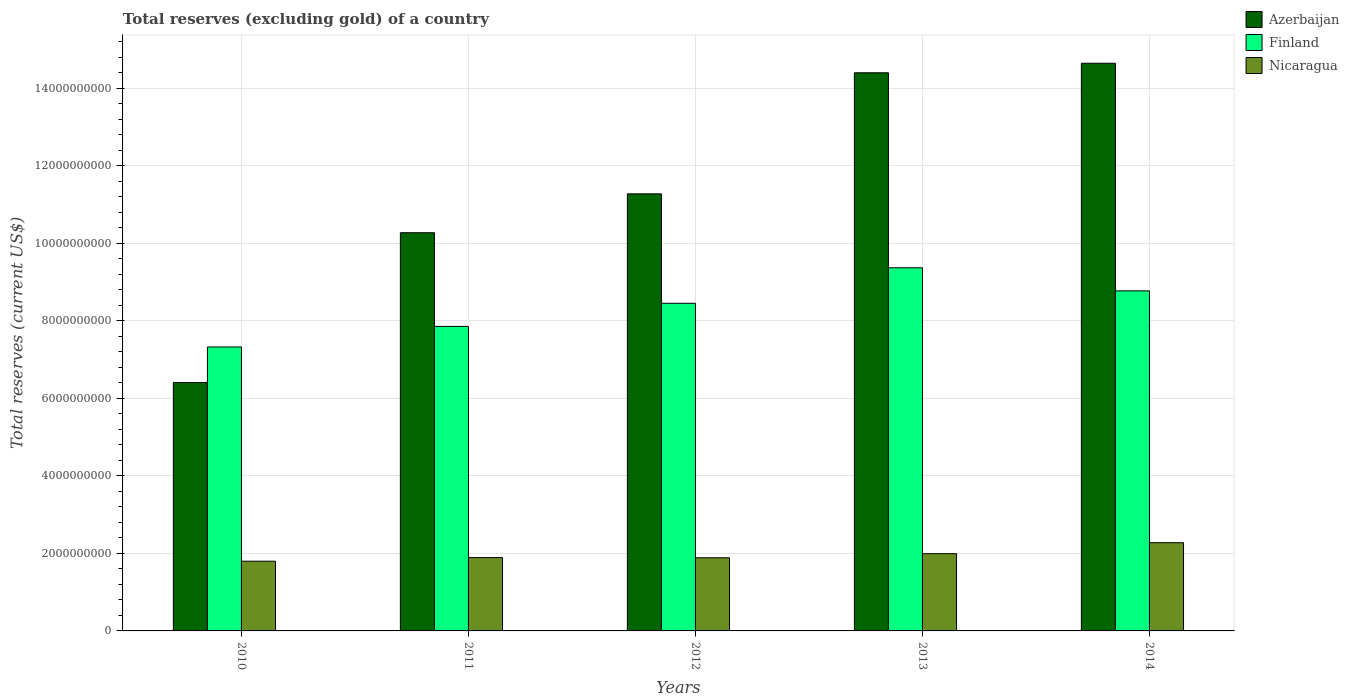Are the number of bars per tick equal to the number of legend labels?
Offer a terse response. Yes. Are the number of bars on each tick of the X-axis equal?
Your response must be concise. Yes. How many bars are there on the 1st tick from the left?
Make the answer very short. 3. How many bars are there on the 3rd tick from the right?
Your answer should be very brief. 3. What is the label of the 4th group of bars from the left?
Provide a succinct answer. 2013. In how many cases, is the number of bars for a given year not equal to the number of legend labels?
Offer a very short reply. 0. What is the total reserves (excluding gold) in Finland in 2010?
Your response must be concise. 7.33e+09. Across all years, what is the maximum total reserves (excluding gold) in Nicaragua?
Make the answer very short. 2.28e+09. Across all years, what is the minimum total reserves (excluding gold) in Nicaragua?
Ensure brevity in your answer.  1.80e+09. What is the total total reserves (excluding gold) in Nicaragua in the graph?
Keep it short and to the point. 9.85e+09. What is the difference between the total reserves (excluding gold) in Azerbaijan in 2011 and that in 2013?
Give a very brief answer. -4.13e+09. What is the difference between the total reserves (excluding gold) in Finland in 2014 and the total reserves (excluding gold) in Azerbaijan in 2012?
Your answer should be very brief. -2.50e+09. What is the average total reserves (excluding gold) in Finland per year?
Your response must be concise. 8.36e+09. In the year 2012, what is the difference between the total reserves (excluding gold) in Azerbaijan and total reserves (excluding gold) in Finland?
Give a very brief answer. 2.82e+09. What is the ratio of the total reserves (excluding gold) in Azerbaijan in 2011 to that in 2013?
Provide a short and direct response. 0.71. Is the total reserves (excluding gold) in Finland in 2011 less than that in 2013?
Your answer should be compact. Yes. What is the difference between the highest and the second highest total reserves (excluding gold) in Azerbaijan?
Provide a succinct answer. 2.46e+08. What is the difference between the highest and the lowest total reserves (excluding gold) in Azerbaijan?
Keep it short and to the point. 8.24e+09. In how many years, is the total reserves (excluding gold) in Finland greater than the average total reserves (excluding gold) in Finland taken over all years?
Provide a succinct answer. 3. Is the sum of the total reserves (excluding gold) in Nicaragua in 2012 and 2013 greater than the maximum total reserves (excluding gold) in Finland across all years?
Provide a short and direct response. No. What does the 1st bar from the left in 2013 represents?
Keep it short and to the point. Azerbaijan. What does the 1st bar from the right in 2013 represents?
Make the answer very short. Nicaragua. Is it the case that in every year, the sum of the total reserves (excluding gold) in Finland and total reserves (excluding gold) in Azerbaijan is greater than the total reserves (excluding gold) in Nicaragua?
Keep it short and to the point. Yes. How many years are there in the graph?
Provide a short and direct response. 5. What is the difference between two consecutive major ticks on the Y-axis?
Your answer should be very brief. 2.00e+09. Are the values on the major ticks of Y-axis written in scientific E-notation?
Provide a short and direct response. No. Does the graph contain any zero values?
Offer a terse response. No. Does the graph contain grids?
Make the answer very short. Yes. What is the title of the graph?
Offer a very short reply. Total reserves (excluding gold) of a country. Does "Zambia" appear as one of the legend labels in the graph?
Offer a terse response. No. What is the label or title of the X-axis?
Your answer should be very brief. Years. What is the label or title of the Y-axis?
Make the answer very short. Total reserves (current US$). What is the Total reserves (current US$) of Azerbaijan in 2010?
Offer a very short reply. 6.41e+09. What is the Total reserves (current US$) in Finland in 2010?
Make the answer very short. 7.33e+09. What is the Total reserves (current US$) in Nicaragua in 2010?
Provide a short and direct response. 1.80e+09. What is the Total reserves (current US$) of Azerbaijan in 2011?
Give a very brief answer. 1.03e+1. What is the Total reserves (current US$) of Finland in 2011?
Your response must be concise. 7.86e+09. What is the Total reserves (current US$) in Nicaragua in 2011?
Your answer should be compact. 1.89e+09. What is the Total reserves (current US$) in Azerbaijan in 2012?
Ensure brevity in your answer.  1.13e+1. What is the Total reserves (current US$) in Finland in 2012?
Ensure brevity in your answer.  8.45e+09. What is the Total reserves (current US$) in Nicaragua in 2012?
Your answer should be very brief. 1.89e+09. What is the Total reserves (current US$) of Azerbaijan in 2013?
Keep it short and to the point. 1.44e+1. What is the Total reserves (current US$) of Finland in 2013?
Ensure brevity in your answer.  9.37e+09. What is the Total reserves (current US$) of Nicaragua in 2013?
Make the answer very short. 1.99e+09. What is the Total reserves (current US$) of Azerbaijan in 2014?
Your answer should be very brief. 1.46e+1. What is the Total reserves (current US$) in Finland in 2014?
Make the answer very short. 8.77e+09. What is the Total reserves (current US$) of Nicaragua in 2014?
Keep it short and to the point. 2.28e+09. Across all years, what is the maximum Total reserves (current US$) in Azerbaijan?
Offer a terse response. 1.46e+1. Across all years, what is the maximum Total reserves (current US$) of Finland?
Ensure brevity in your answer.  9.37e+09. Across all years, what is the maximum Total reserves (current US$) in Nicaragua?
Provide a succinct answer. 2.28e+09. Across all years, what is the minimum Total reserves (current US$) of Azerbaijan?
Provide a succinct answer. 6.41e+09. Across all years, what is the minimum Total reserves (current US$) in Finland?
Ensure brevity in your answer.  7.33e+09. Across all years, what is the minimum Total reserves (current US$) of Nicaragua?
Offer a very short reply. 1.80e+09. What is the total Total reserves (current US$) of Azerbaijan in the graph?
Keep it short and to the point. 5.70e+1. What is the total Total reserves (current US$) in Finland in the graph?
Keep it short and to the point. 4.18e+1. What is the total Total reserves (current US$) of Nicaragua in the graph?
Your response must be concise. 9.85e+09. What is the difference between the Total reserves (current US$) of Azerbaijan in 2010 and that in 2011?
Offer a very short reply. -3.86e+09. What is the difference between the Total reserves (current US$) of Finland in 2010 and that in 2011?
Ensure brevity in your answer.  -5.30e+08. What is the difference between the Total reserves (current US$) in Nicaragua in 2010 and that in 2011?
Your response must be concise. -9.33e+07. What is the difference between the Total reserves (current US$) of Azerbaijan in 2010 and that in 2012?
Your response must be concise. -4.87e+09. What is the difference between the Total reserves (current US$) in Finland in 2010 and that in 2012?
Offer a very short reply. -1.13e+09. What is the difference between the Total reserves (current US$) in Nicaragua in 2010 and that in 2012?
Make the answer very short. -8.82e+07. What is the difference between the Total reserves (current US$) in Azerbaijan in 2010 and that in 2013?
Provide a short and direct response. -7.99e+09. What is the difference between the Total reserves (current US$) of Finland in 2010 and that in 2013?
Give a very brief answer. -2.04e+09. What is the difference between the Total reserves (current US$) of Nicaragua in 2010 and that in 2013?
Give a very brief answer. -1.94e+08. What is the difference between the Total reserves (current US$) of Azerbaijan in 2010 and that in 2014?
Make the answer very short. -8.24e+09. What is the difference between the Total reserves (current US$) in Finland in 2010 and that in 2014?
Your answer should be compact. -1.45e+09. What is the difference between the Total reserves (current US$) in Nicaragua in 2010 and that in 2014?
Provide a succinct answer. -4.77e+08. What is the difference between the Total reserves (current US$) of Azerbaijan in 2011 and that in 2012?
Give a very brief answer. -1.00e+09. What is the difference between the Total reserves (current US$) of Finland in 2011 and that in 2012?
Provide a short and direct response. -5.96e+08. What is the difference between the Total reserves (current US$) in Nicaragua in 2011 and that in 2012?
Your response must be concise. 5.03e+06. What is the difference between the Total reserves (current US$) in Azerbaijan in 2011 and that in 2013?
Provide a succinct answer. -4.13e+09. What is the difference between the Total reserves (current US$) in Finland in 2011 and that in 2013?
Keep it short and to the point. -1.51e+09. What is the difference between the Total reserves (current US$) in Nicaragua in 2011 and that in 2013?
Ensure brevity in your answer.  -1.01e+08. What is the difference between the Total reserves (current US$) in Azerbaijan in 2011 and that in 2014?
Offer a very short reply. -4.37e+09. What is the difference between the Total reserves (current US$) of Finland in 2011 and that in 2014?
Keep it short and to the point. -9.17e+08. What is the difference between the Total reserves (current US$) in Nicaragua in 2011 and that in 2014?
Your answer should be very brief. -3.84e+08. What is the difference between the Total reserves (current US$) of Azerbaijan in 2012 and that in 2013?
Make the answer very short. -3.12e+09. What is the difference between the Total reserves (current US$) of Finland in 2012 and that in 2013?
Make the answer very short. -9.16e+08. What is the difference between the Total reserves (current US$) in Nicaragua in 2012 and that in 2013?
Offer a very short reply. -1.06e+08. What is the difference between the Total reserves (current US$) of Azerbaijan in 2012 and that in 2014?
Make the answer very short. -3.37e+09. What is the difference between the Total reserves (current US$) of Finland in 2012 and that in 2014?
Provide a short and direct response. -3.21e+08. What is the difference between the Total reserves (current US$) of Nicaragua in 2012 and that in 2014?
Keep it short and to the point. -3.89e+08. What is the difference between the Total reserves (current US$) of Azerbaijan in 2013 and that in 2014?
Give a very brief answer. -2.46e+08. What is the difference between the Total reserves (current US$) of Finland in 2013 and that in 2014?
Your response must be concise. 5.95e+08. What is the difference between the Total reserves (current US$) of Nicaragua in 2013 and that in 2014?
Your answer should be very brief. -2.83e+08. What is the difference between the Total reserves (current US$) of Azerbaijan in 2010 and the Total reserves (current US$) of Finland in 2011?
Provide a short and direct response. -1.45e+09. What is the difference between the Total reserves (current US$) of Azerbaijan in 2010 and the Total reserves (current US$) of Nicaragua in 2011?
Offer a terse response. 4.52e+09. What is the difference between the Total reserves (current US$) of Finland in 2010 and the Total reserves (current US$) of Nicaragua in 2011?
Keep it short and to the point. 5.43e+09. What is the difference between the Total reserves (current US$) of Azerbaijan in 2010 and the Total reserves (current US$) of Finland in 2012?
Your answer should be compact. -2.04e+09. What is the difference between the Total reserves (current US$) of Azerbaijan in 2010 and the Total reserves (current US$) of Nicaragua in 2012?
Make the answer very short. 4.52e+09. What is the difference between the Total reserves (current US$) in Finland in 2010 and the Total reserves (current US$) in Nicaragua in 2012?
Offer a terse response. 5.44e+09. What is the difference between the Total reserves (current US$) in Azerbaijan in 2010 and the Total reserves (current US$) in Finland in 2013?
Offer a very short reply. -2.96e+09. What is the difference between the Total reserves (current US$) in Azerbaijan in 2010 and the Total reserves (current US$) in Nicaragua in 2013?
Keep it short and to the point. 4.42e+09. What is the difference between the Total reserves (current US$) of Finland in 2010 and the Total reserves (current US$) of Nicaragua in 2013?
Provide a succinct answer. 5.33e+09. What is the difference between the Total reserves (current US$) in Azerbaijan in 2010 and the Total reserves (current US$) in Finland in 2014?
Provide a short and direct response. -2.36e+09. What is the difference between the Total reserves (current US$) in Azerbaijan in 2010 and the Total reserves (current US$) in Nicaragua in 2014?
Give a very brief answer. 4.13e+09. What is the difference between the Total reserves (current US$) of Finland in 2010 and the Total reserves (current US$) of Nicaragua in 2014?
Keep it short and to the point. 5.05e+09. What is the difference between the Total reserves (current US$) in Azerbaijan in 2011 and the Total reserves (current US$) in Finland in 2012?
Provide a short and direct response. 1.82e+09. What is the difference between the Total reserves (current US$) in Azerbaijan in 2011 and the Total reserves (current US$) in Nicaragua in 2012?
Give a very brief answer. 8.39e+09. What is the difference between the Total reserves (current US$) of Finland in 2011 and the Total reserves (current US$) of Nicaragua in 2012?
Offer a terse response. 5.97e+09. What is the difference between the Total reserves (current US$) in Azerbaijan in 2011 and the Total reserves (current US$) in Finland in 2013?
Your answer should be compact. 9.05e+08. What is the difference between the Total reserves (current US$) in Azerbaijan in 2011 and the Total reserves (current US$) in Nicaragua in 2013?
Keep it short and to the point. 8.28e+09. What is the difference between the Total reserves (current US$) in Finland in 2011 and the Total reserves (current US$) in Nicaragua in 2013?
Provide a succinct answer. 5.86e+09. What is the difference between the Total reserves (current US$) of Azerbaijan in 2011 and the Total reserves (current US$) of Finland in 2014?
Your answer should be very brief. 1.50e+09. What is the difference between the Total reserves (current US$) in Azerbaijan in 2011 and the Total reserves (current US$) in Nicaragua in 2014?
Give a very brief answer. 8.00e+09. What is the difference between the Total reserves (current US$) in Finland in 2011 and the Total reserves (current US$) in Nicaragua in 2014?
Your response must be concise. 5.58e+09. What is the difference between the Total reserves (current US$) of Azerbaijan in 2012 and the Total reserves (current US$) of Finland in 2013?
Your answer should be compact. 1.91e+09. What is the difference between the Total reserves (current US$) in Azerbaijan in 2012 and the Total reserves (current US$) in Nicaragua in 2013?
Offer a very short reply. 9.28e+09. What is the difference between the Total reserves (current US$) of Finland in 2012 and the Total reserves (current US$) of Nicaragua in 2013?
Make the answer very short. 6.46e+09. What is the difference between the Total reserves (current US$) of Azerbaijan in 2012 and the Total reserves (current US$) of Finland in 2014?
Your response must be concise. 2.50e+09. What is the difference between the Total reserves (current US$) in Azerbaijan in 2012 and the Total reserves (current US$) in Nicaragua in 2014?
Offer a very short reply. 9.00e+09. What is the difference between the Total reserves (current US$) in Finland in 2012 and the Total reserves (current US$) in Nicaragua in 2014?
Offer a terse response. 6.18e+09. What is the difference between the Total reserves (current US$) in Azerbaijan in 2013 and the Total reserves (current US$) in Finland in 2014?
Give a very brief answer. 5.63e+09. What is the difference between the Total reserves (current US$) of Azerbaijan in 2013 and the Total reserves (current US$) of Nicaragua in 2014?
Keep it short and to the point. 1.21e+1. What is the difference between the Total reserves (current US$) in Finland in 2013 and the Total reserves (current US$) in Nicaragua in 2014?
Your response must be concise. 7.09e+09. What is the average Total reserves (current US$) in Azerbaijan per year?
Your answer should be compact. 1.14e+1. What is the average Total reserves (current US$) in Finland per year?
Make the answer very short. 8.36e+09. What is the average Total reserves (current US$) in Nicaragua per year?
Offer a very short reply. 1.97e+09. In the year 2010, what is the difference between the Total reserves (current US$) of Azerbaijan and Total reserves (current US$) of Finland?
Make the answer very short. -9.18e+08. In the year 2010, what is the difference between the Total reserves (current US$) in Azerbaijan and Total reserves (current US$) in Nicaragua?
Your answer should be very brief. 4.61e+09. In the year 2010, what is the difference between the Total reserves (current US$) in Finland and Total reserves (current US$) in Nicaragua?
Provide a succinct answer. 5.53e+09. In the year 2011, what is the difference between the Total reserves (current US$) in Azerbaijan and Total reserves (current US$) in Finland?
Offer a terse response. 2.42e+09. In the year 2011, what is the difference between the Total reserves (current US$) of Azerbaijan and Total reserves (current US$) of Nicaragua?
Provide a short and direct response. 8.38e+09. In the year 2011, what is the difference between the Total reserves (current US$) of Finland and Total reserves (current US$) of Nicaragua?
Your answer should be very brief. 5.96e+09. In the year 2012, what is the difference between the Total reserves (current US$) in Azerbaijan and Total reserves (current US$) in Finland?
Ensure brevity in your answer.  2.82e+09. In the year 2012, what is the difference between the Total reserves (current US$) of Azerbaijan and Total reserves (current US$) of Nicaragua?
Ensure brevity in your answer.  9.39e+09. In the year 2012, what is the difference between the Total reserves (current US$) in Finland and Total reserves (current US$) in Nicaragua?
Offer a very short reply. 6.57e+09. In the year 2013, what is the difference between the Total reserves (current US$) of Azerbaijan and Total reserves (current US$) of Finland?
Offer a terse response. 5.03e+09. In the year 2013, what is the difference between the Total reserves (current US$) of Azerbaijan and Total reserves (current US$) of Nicaragua?
Provide a short and direct response. 1.24e+1. In the year 2013, what is the difference between the Total reserves (current US$) of Finland and Total reserves (current US$) of Nicaragua?
Make the answer very short. 7.38e+09. In the year 2014, what is the difference between the Total reserves (current US$) in Azerbaijan and Total reserves (current US$) in Finland?
Offer a terse response. 5.87e+09. In the year 2014, what is the difference between the Total reserves (current US$) of Azerbaijan and Total reserves (current US$) of Nicaragua?
Offer a very short reply. 1.24e+1. In the year 2014, what is the difference between the Total reserves (current US$) of Finland and Total reserves (current US$) of Nicaragua?
Offer a terse response. 6.50e+09. What is the ratio of the Total reserves (current US$) of Azerbaijan in 2010 to that in 2011?
Your answer should be compact. 0.62. What is the ratio of the Total reserves (current US$) in Finland in 2010 to that in 2011?
Offer a terse response. 0.93. What is the ratio of the Total reserves (current US$) of Nicaragua in 2010 to that in 2011?
Your answer should be compact. 0.95. What is the ratio of the Total reserves (current US$) in Azerbaijan in 2010 to that in 2012?
Keep it short and to the point. 0.57. What is the ratio of the Total reserves (current US$) of Finland in 2010 to that in 2012?
Keep it short and to the point. 0.87. What is the ratio of the Total reserves (current US$) in Nicaragua in 2010 to that in 2012?
Ensure brevity in your answer.  0.95. What is the ratio of the Total reserves (current US$) in Azerbaijan in 2010 to that in 2013?
Provide a succinct answer. 0.45. What is the ratio of the Total reserves (current US$) in Finland in 2010 to that in 2013?
Provide a succinct answer. 0.78. What is the ratio of the Total reserves (current US$) of Nicaragua in 2010 to that in 2013?
Give a very brief answer. 0.9. What is the ratio of the Total reserves (current US$) of Azerbaijan in 2010 to that in 2014?
Keep it short and to the point. 0.44. What is the ratio of the Total reserves (current US$) of Finland in 2010 to that in 2014?
Offer a very short reply. 0.84. What is the ratio of the Total reserves (current US$) of Nicaragua in 2010 to that in 2014?
Make the answer very short. 0.79. What is the ratio of the Total reserves (current US$) of Azerbaijan in 2011 to that in 2012?
Your answer should be compact. 0.91. What is the ratio of the Total reserves (current US$) of Finland in 2011 to that in 2012?
Offer a very short reply. 0.93. What is the ratio of the Total reserves (current US$) of Azerbaijan in 2011 to that in 2013?
Provide a succinct answer. 0.71. What is the ratio of the Total reserves (current US$) of Finland in 2011 to that in 2013?
Give a very brief answer. 0.84. What is the ratio of the Total reserves (current US$) of Nicaragua in 2011 to that in 2013?
Provide a short and direct response. 0.95. What is the ratio of the Total reserves (current US$) in Azerbaijan in 2011 to that in 2014?
Offer a terse response. 0.7. What is the ratio of the Total reserves (current US$) of Finland in 2011 to that in 2014?
Give a very brief answer. 0.9. What is the ratio of the Total reserves (current US$) in Nicaragua in 2011 to that in 2014?
Your answer should be very brief. 0.83. What is the ratio of the Total reserves (current US$) in Azerbaijan in 2012 to that in 2013?
Your response must be concise. 0.78. What is the ratio of the Total reserves (current US$) of Finland in 2012 to that in 2013?
Provide a short and direct response. 0.9. What is the ratio of the Total reserves (current US$) of Nicaragua in 2012 to that in 2013?
Offer a terse response. 0.95. What is the ratio of the Total reserves (current US$) in Azerbaijan in 2012 to that in 2014?
Provide a succinct answer. 0.77. What is the ratio of the Total reserves (current US$) of Finland in 2012 to that in 2014?
Provide a succinct answer. 0.96. What is the ratio of the Total reserves (current US$) in Nicaragua in 2012 to that in 2014?
Provide a short and direct response. 0.83. What is the ratio of the Total reserves (current US$) of Azerbaijan in 2013 to that in 2014?
Offer a terse response. 0.98. What is the ratio of the Total reserves (current US$) in Finland in 2013 to that in 2014?
Offer a very short reply. 1.07. What is the ratio of the Total reserves (current US$) in Nicaragua in 2013 to that in 2014?
Offer a terse response. 0.88. What is the difference between the highest and the second highest Total reserves (current US$) of Azerbaijan?
Your response must be concise. 2.46e+08. What is the difference between the highest and the second highest Total reserves (current US$) in Finland?
Your response must be concise. 5.95e+08. What is the difference between the highest and the second highest Total reserves (current US$) of Nicaragua?
Offer a very short reply. 2.83e+08. What is the difference between the highest and the lowest Total reserves (current US$) in Azerbaijan?
Your answer should be very brief. 8.24e+09. What is the difference between the highest and the lowest Total reserves (current US$) in Finland?
Ensure brevity in your answer.  2.04e+09. What is the difference between the highest and the lowest Total reserves (current US$) of Nicaragua?
Offer a terse response. 4.77e+08. 